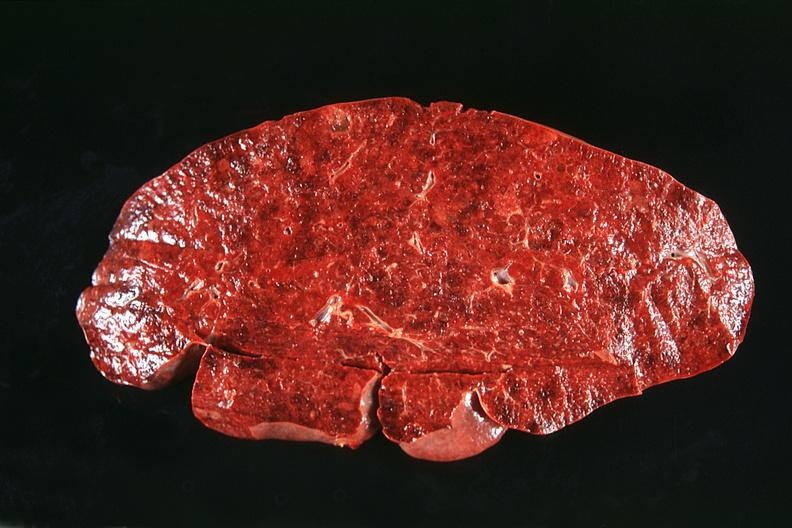where is this part in?
Answer the question using a single word or phrase. Spleen 